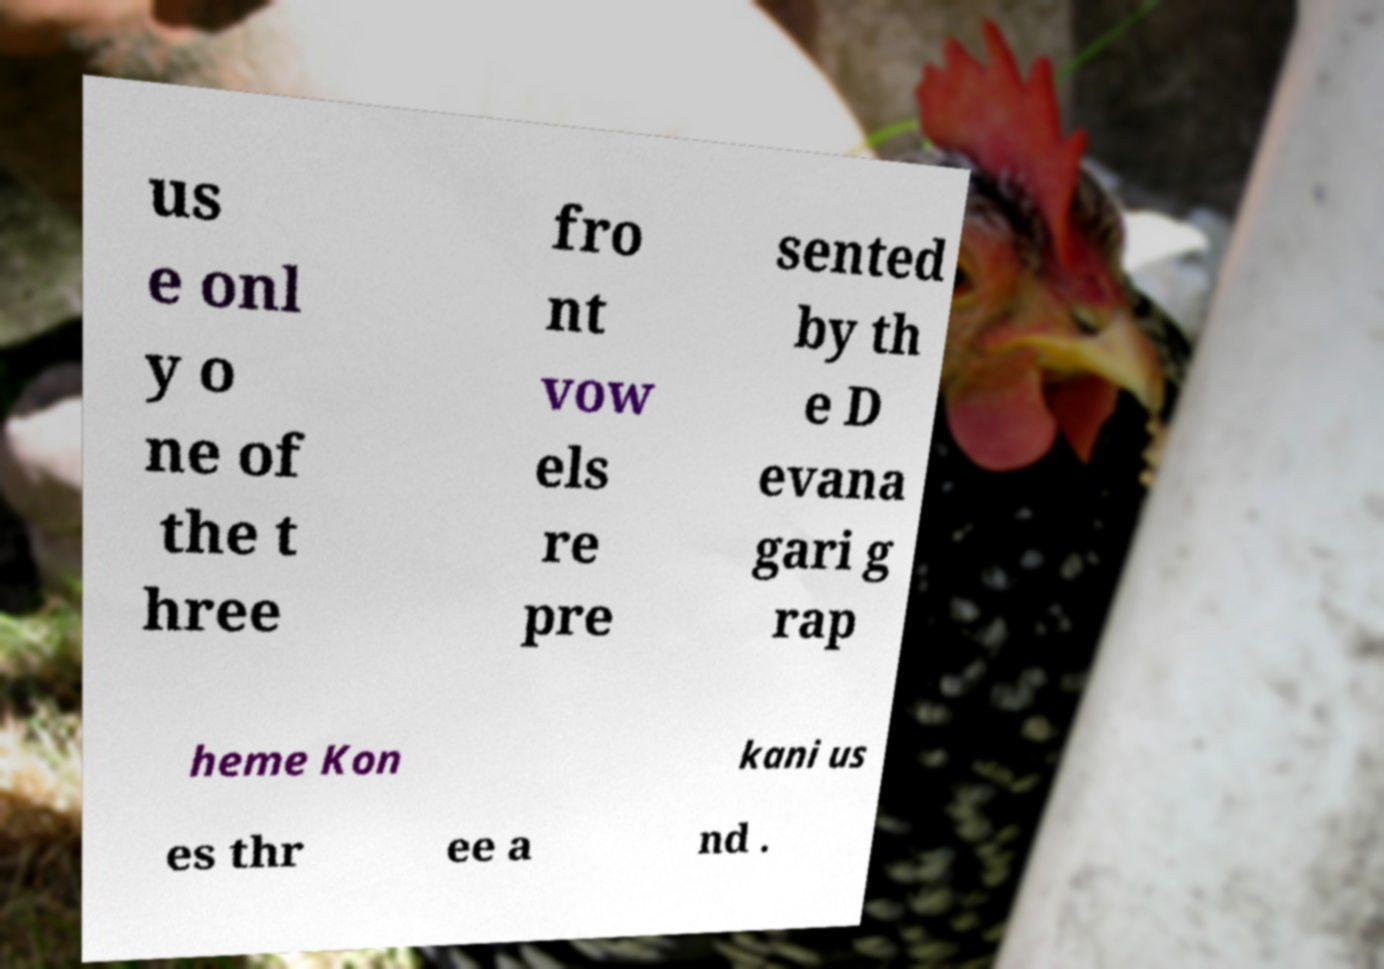Please read and relay the text visible in this image. What does it say? us e onl y o ne of the t hree fro nt vow els re pre sented by th e D evana gari g rap heme Kon kani us es thr ee a nd . 